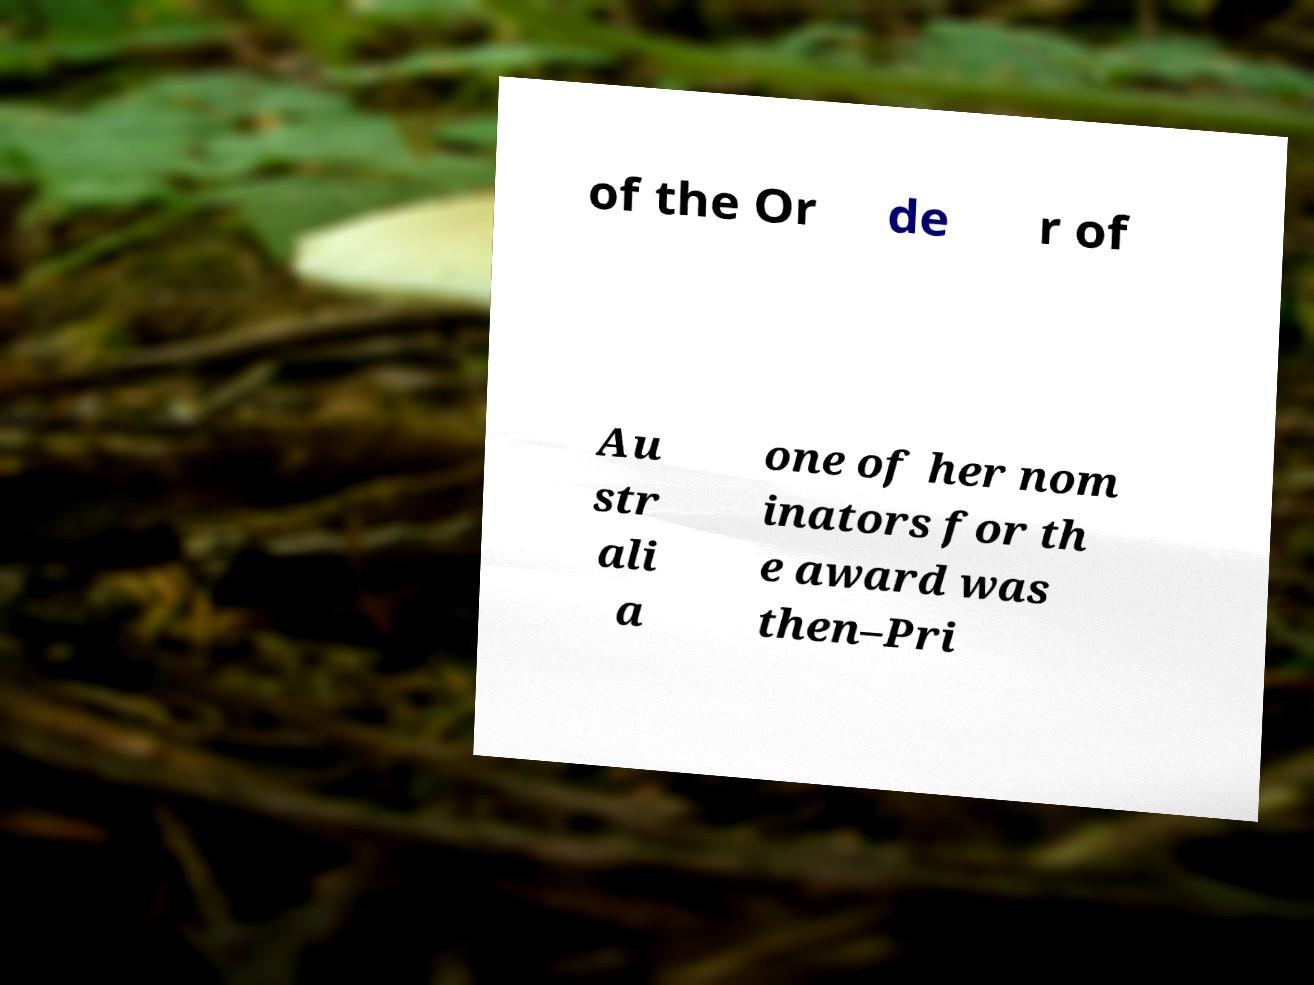There's text embedded in this image that I need extracted. Can you transcribe it verbatim? of the Or de r of Au str ali a one of her nom inators for th e award was then–Pri 